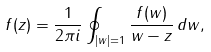Convert formula to latex. <formula><loc_0><loc_0><loc_500><loc_500>f ( z ) = \frac { 1 } { 2 \pi i } \oint _ { | w | = 1 } \frac { f ( w ) } { w - z } \, d w ,</formula> 